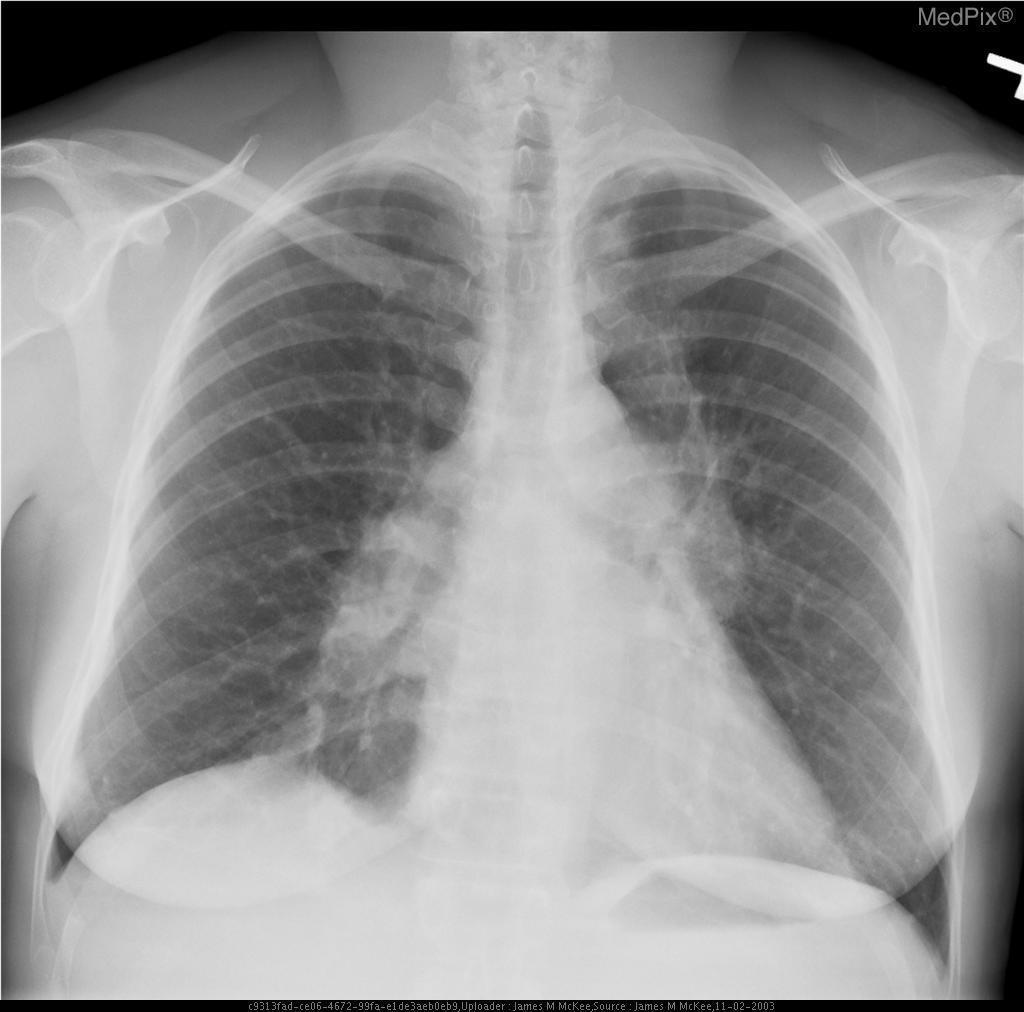Is the image normal?
Keep it brief. No. What are the lesions indicative of?
Give a very brief answer. Adenopathy. What are the lesions consistent with?
Keep it brief. Infection. Where are the lesions located?
Keep it brief. Paratracheal area. Where are the lesions?
Concise answer only. Paratracheal area. How is the image oriented?
Give a very brief answer. Pa. What plane is this x-ray in?
Concise answer only. Pa. 